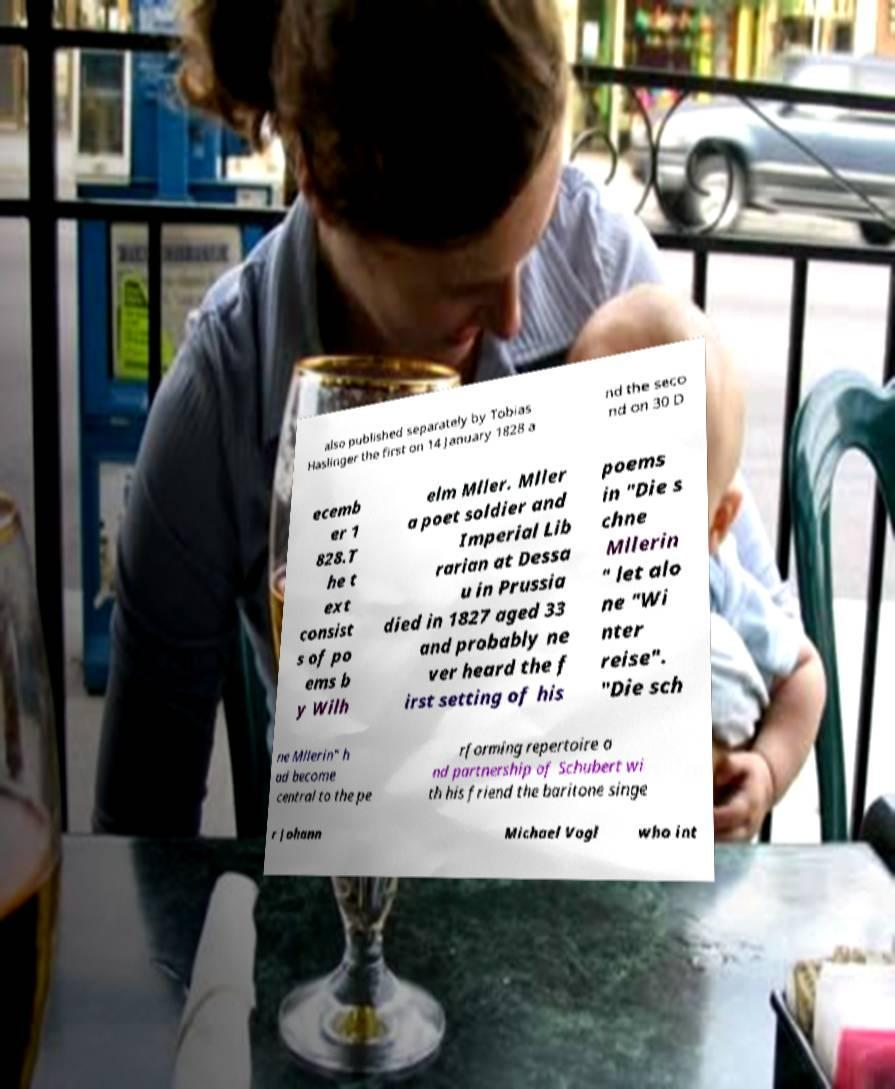Please read and relay the text visible in this image. What does it say? also published separately by Tobias Haslinger the first on 14 January 1828 a nd the seco nd on 30 D ecemb er 1 828.T he t ext consist s of po ems b y Wilh elm Mller. Mller a poet soldier and Imperial Lib rarian at Dessa u in Prussia died in 1827 aged 33 and probably ne ver heard the f irst setting of his poems in "Die s chne Mllerin " let alo ne "Wi nter reise". "Die sch ne Mllerin" h ad become central to the pe rforming repertoire a nd partnership of Schubert wi th his friend the baritone singe r Johann Michael Vogl who int 